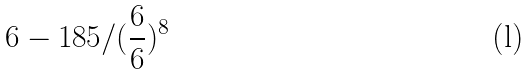Convert formula to latex. <formula><loc_0><loc_0><loc_500><loc_500>6 - 1 8 5 / ( \frac { 6 } { 6 } ) ^ { 8 }</formula> 